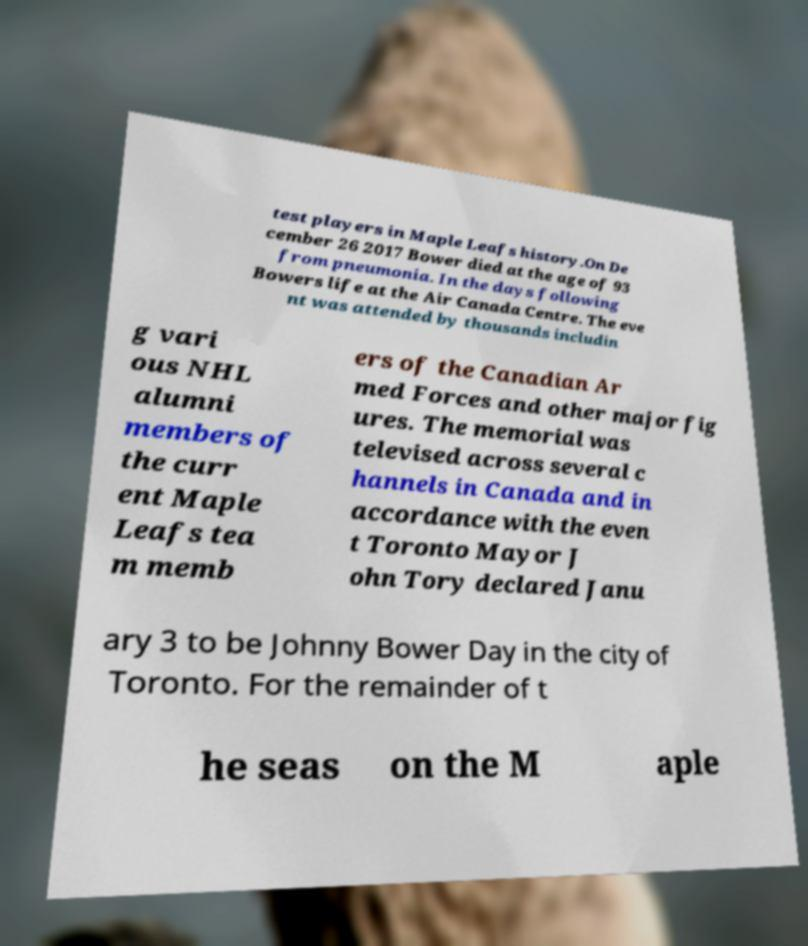Please read and relay the text visible in this image. What does it say? test players in Maple Leafs history.On De cember 26 2017 Bower died at the age of 93 from pneumonia. In the days following Bowers life at the Air Canada Centre. The eve nt was attended by thousands includin g vari ous NHL alumni members of the curr ent Maple Leafs tea m memb ers of the Canadian Ar med Forces and other major fig ures. The memorial was televised across several c hannels in Canada and in accordance with the even t Toronto Mayor J ohn Tory declared Janu ary 3 to be Johnny Bower Day in the city of Toronto. For the remainder of t he seas on the M aple 